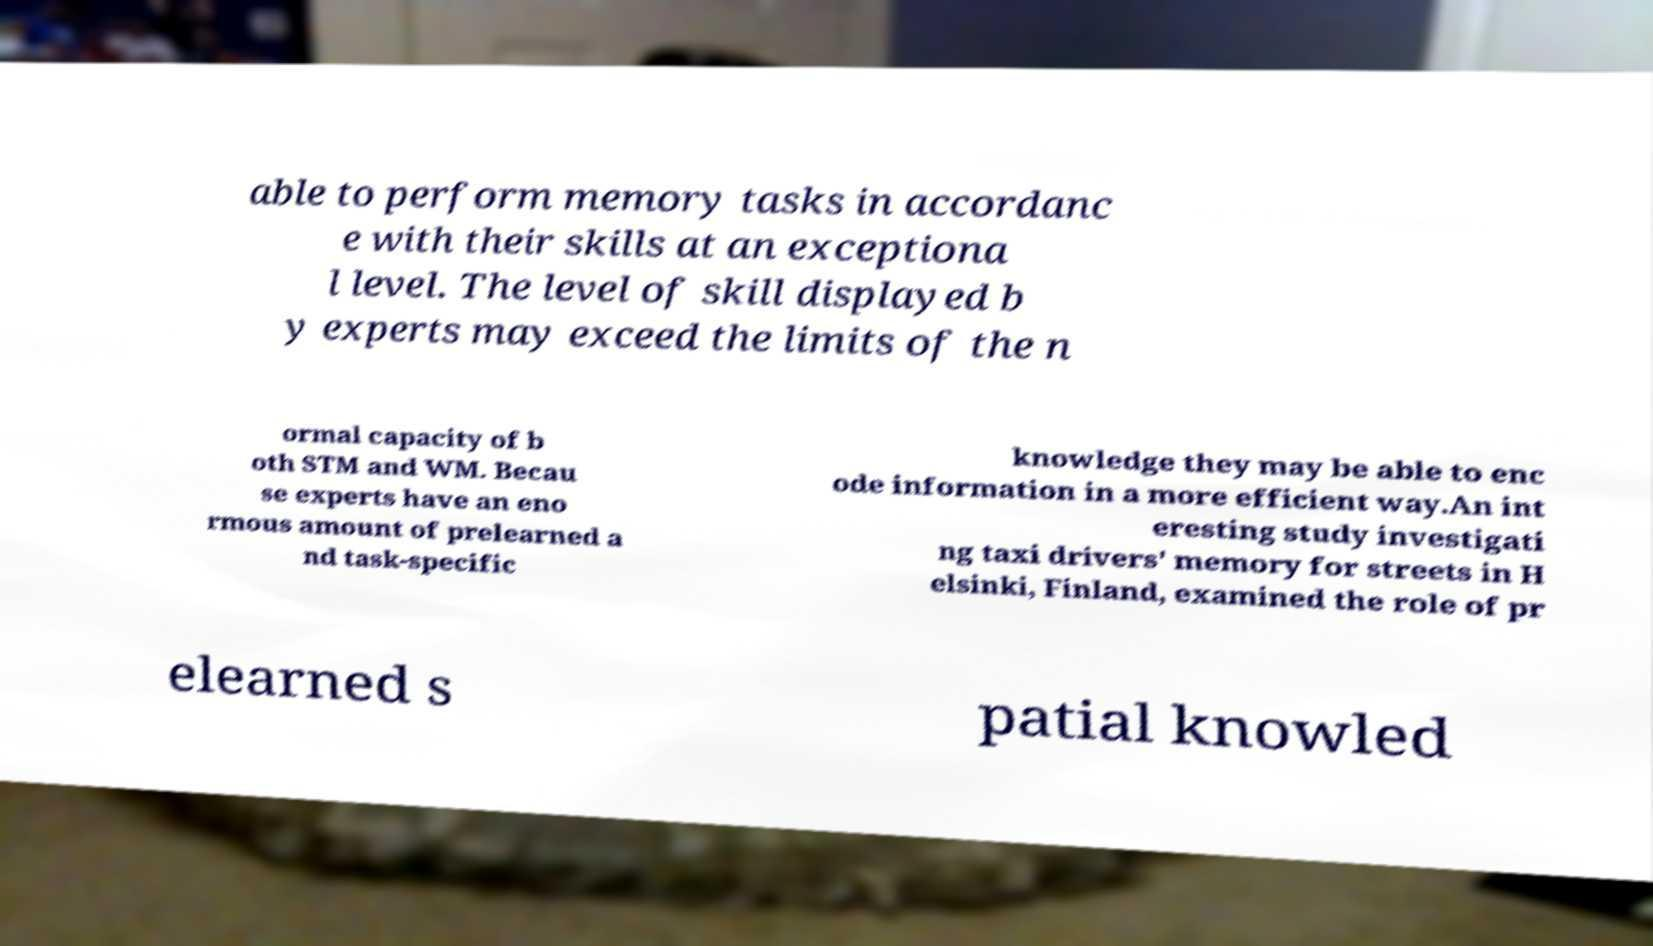Can you accurately transcribe the text from the provided image for me? able to perform memory tasks in accordanc e with their skills at an exceptiona l level. The level of skill displayed b y experts may exceed the limits of the n ormal capacity of b oth STM and WM. Becau se experts have an eno rmous amount of prelearned a nd task-specific knowledge they may be able to enc ode information in a more efficient way.An int eresting study investigati ng taxi drivers' memory for streets in H elsinki, Finland, examined the role of pr elearned s patial knowled 